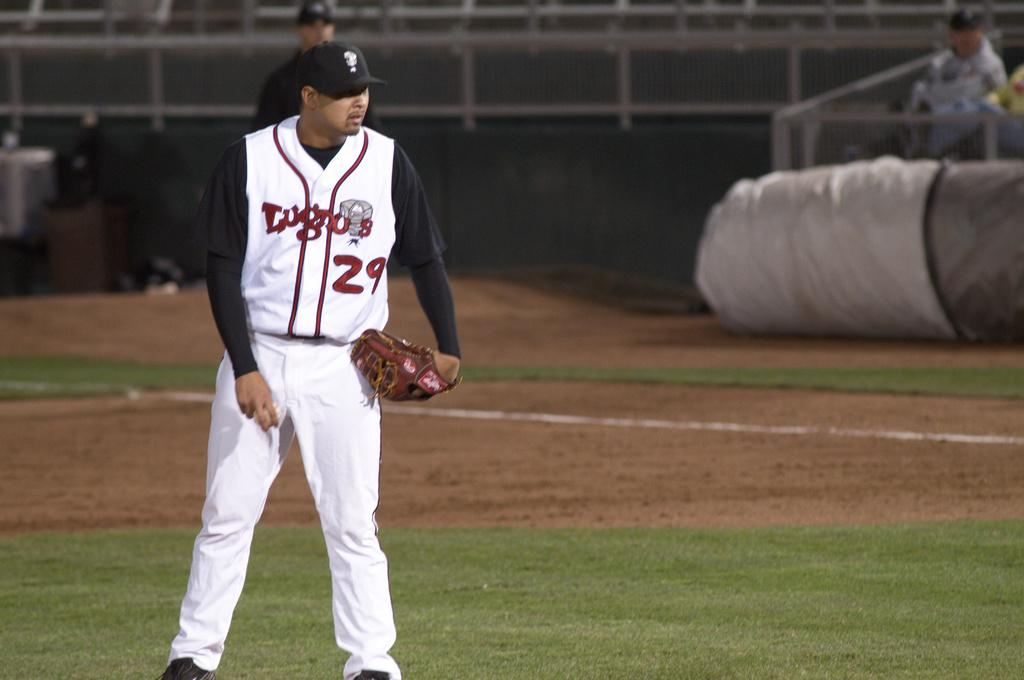<image>
Relay a brief, clear account of the picture shown. Baseball Pitcher looking at home plate, where Lugno's # 29 Jersey. 